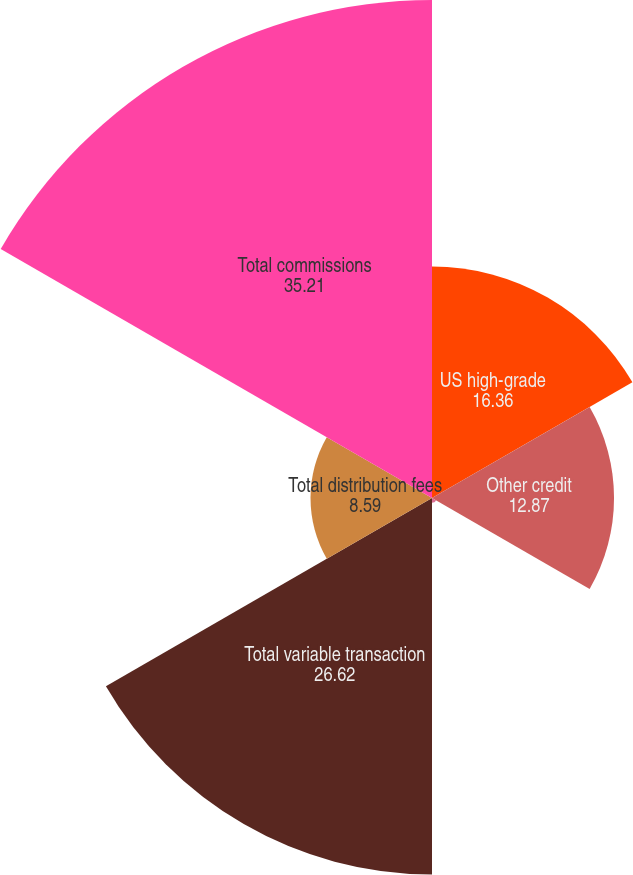<chart> <loc_0><loc_0><loc_500><loc_500><pie_chart><fcel>US high-grade<fcel>Other credit<fcel>Liquid products<fcel>Total variable transaction<fcel>Total distribution fees<fcel>Total commissions<nl><fcel>16.36%<fcel>12.87%<fcel>0.34%<fcel>26.62%<fcel>8.59%<fcel>35.21%<nl></chart> 